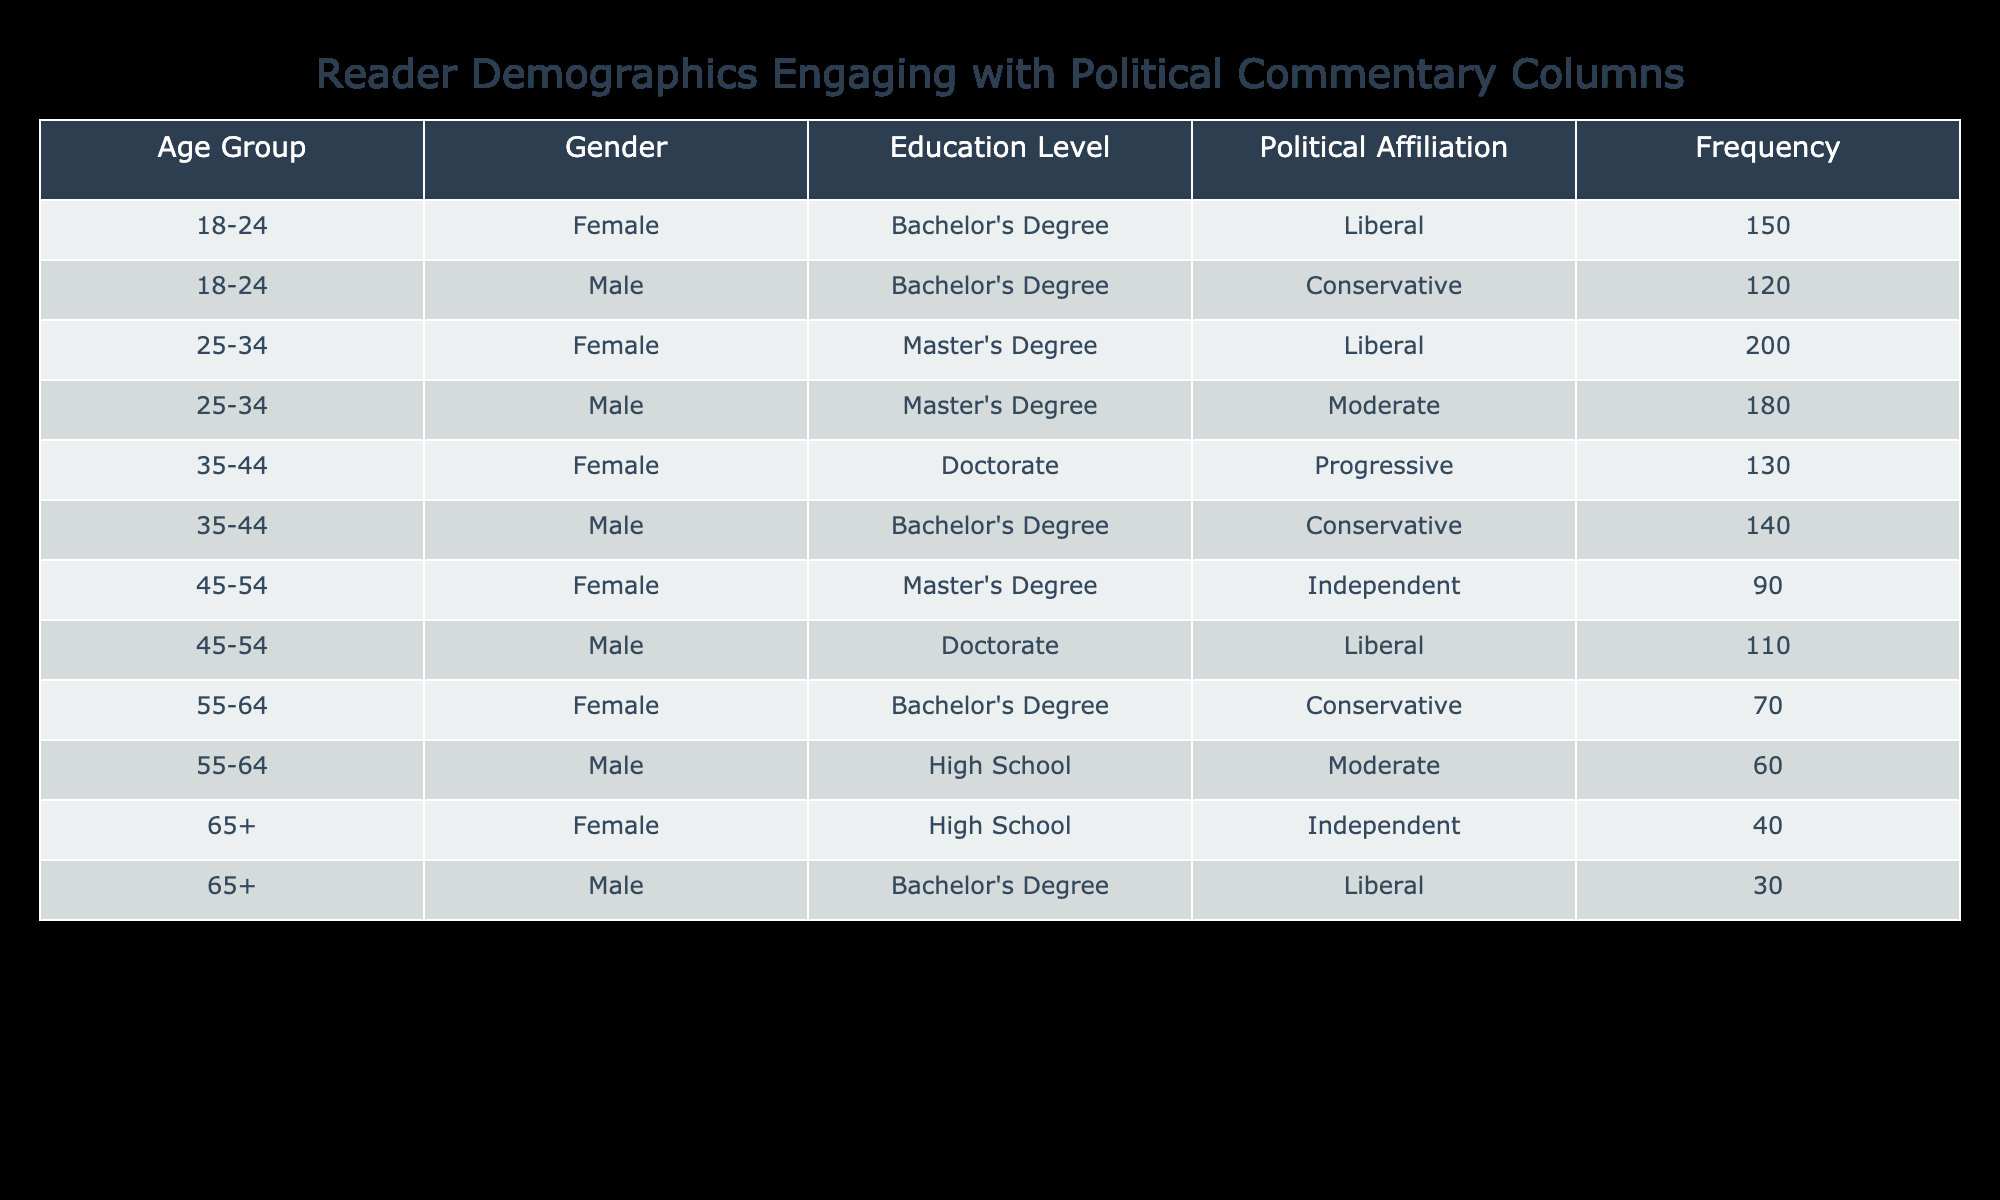What is the frequency of female readers in the 18-24 age group? According to the table, the frequency of female readers aged 18-24 is 150. This value is listed directly under the corresponding row for the specified demographic in the table.
Answer: 150 What is the total frequency of male readers across all age groups? To find the total frequency of male readers, we need to sum the frequencies listed for all male entries: 120 (18-24, Conservative) + 180 (25-34, Moderate) + 140 (35-44, Conservative) + 110 (45-54, Liberal) + 60 (55-64, Moderate) + 30 (65+, Liberal) = 700.
Answer: 700 Which age group has the highest frequency of readers? By reviewing the frequency values across all age groups, we find that the age group 25-34 has the highest frequency with a total of 200, as this is the largest individual value in the frequency column when comparing all age groups.
Answer: 25-34 Is there a higher frequency of readers with a Master's Degree compared to those with a Bachelor's Degree? To determine this, we compare the total frequencies of each education level. Master's Degree frequencies: 200 (25-34, Liberal) + 90 (45-54, Independent) = 290. Bachelor's Degree frequencies: 150 (18-24, Liberal) + 120 (18-24, Conservative) + 140 (35-44, Conservative) + 70 (55-64, Conservative) + 30 (65+, Liberal) = 510. Since 510 > 290, the answer is no, there is not a higher frequency of readers with a Master's Degree.
Answer: No What is the difference in frequency between the political affiliations of Liberal and Conservative readers? We first sum the frequencies of Liberal readers: 150 (18-24, Female) + 200 (25-34, Female) + 110 (45-54, Male) + 30 (65+, Male) = 490. Then we sum Conservative readers: 120 (18-24, Male) + 140 (35-44, Male) + 70 (55-64, Female) = 330. Finally, we find the difference: 490 - 330 = 160.
Answer: 160 